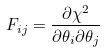Convert formula to latex. <formula><loc_0><loc_0><loc_500><loc_500>F _ { i j } = \frac { \partial \chi ^ { 2 } } { \partial \theta _ { i } \partial \theta _ { j } }</formula> 